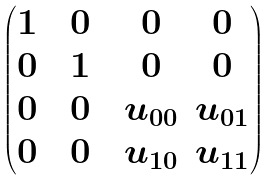<formula> <loc_0><loc_0><loc_500><loc_500>\begin{pmatrix} 1 & & 0 & & 0 & 0 \\ 0 & & 1 & & 0 & 0 \\ 0 & & 0 & & u _ { 0 0 } & u _ { 0 1 } \\ 0 & & 0 & & u _ { 1 0 } & u _ { 1 1 } \\ \end{pmatrix}</formula> 